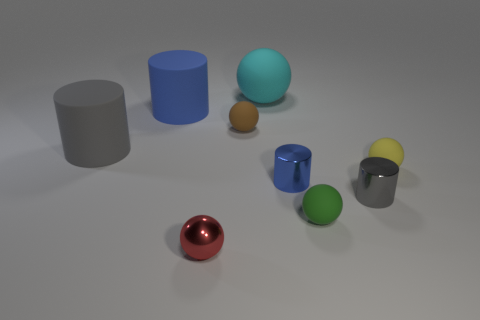Subtract all yellow balls. How many balls are left? 4 Subtract all tiny brown rubber balls. How many balls are left? 4 Add 1 large green matte blocks. How many objects exist? 10 Subtract all brown cylinders. Subtract all blue spheres. How many cylinders are left? 4 Subtract all spheres. How many objects are left? 4 Add 8 blue metallic cylinders. How many blue metallic cylinders are left? 9 Add 5 tiny cyan rubber cubes. How many tiny cyan rubber cubes exist? 5 Subtract 0 blue cubes. How many objects are left? 9 Subtract all gray objects. Subtract all matte cylinders. How many objects are left? 5 